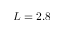Convert formula to latex. <formula><loc_0><loc_0><loc_500><loc_500>L = 2 . 8</formula> 